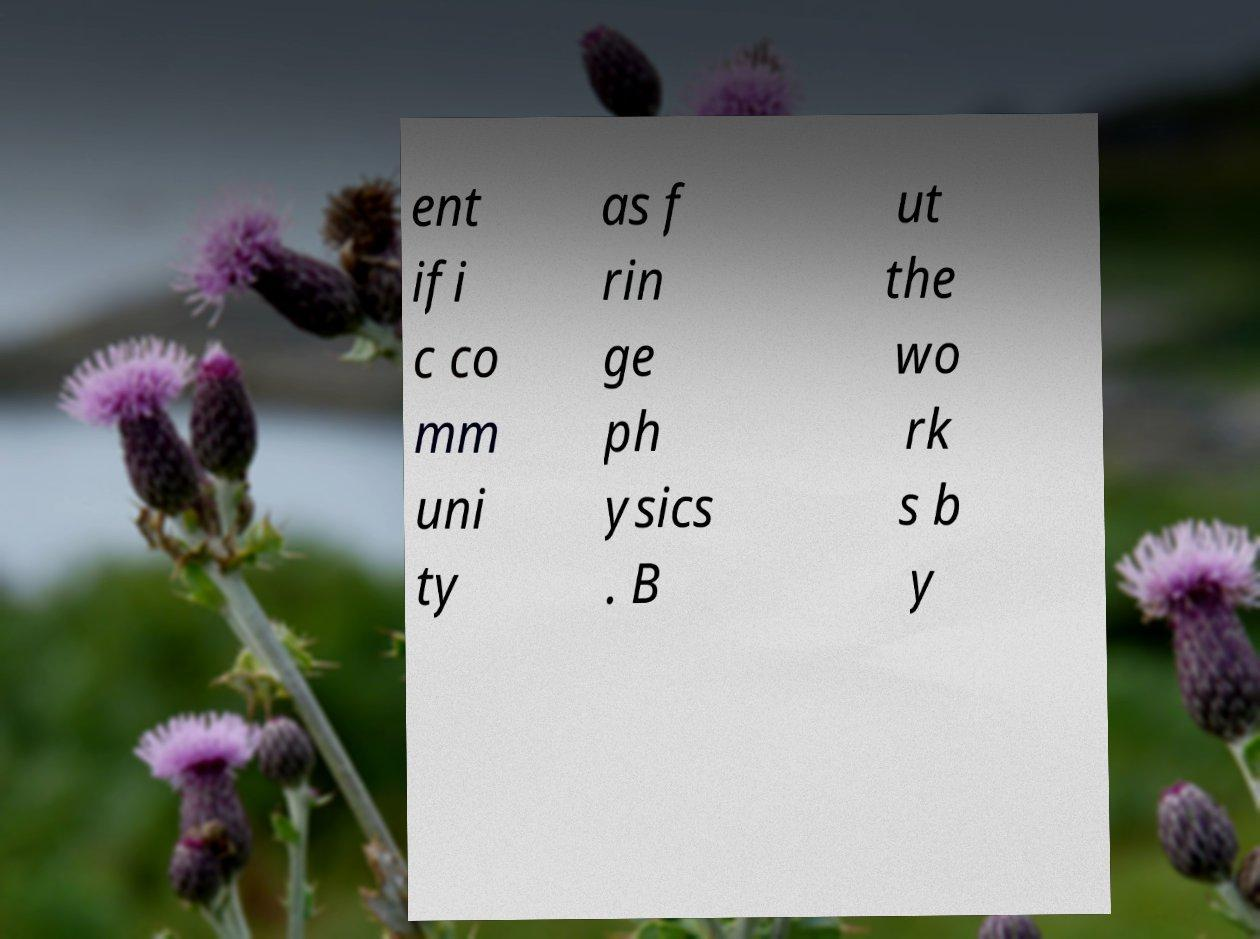Please identify and transcribe the text found in this image. ent ifi c co mm uni ty as f rin ge ph ysics . B ut the wo rk s b y 